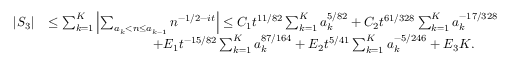<formula> <loc_0><loc_0><loc_500><loc_500>\begin{array} { r l } { | S _ { 3 } | } & { \leq \sum _ { k = 1 } ^ { K } \left | \sum _ { a _ { k } < n \leq a _ { k - 1 } } n ^ { - 1 / 2 - i t } \right | \leq C _ { 1 } t ^ { 1 1 / 8 2 } \sum _ { k = 1 } ^ { K } a _ { k } ^ { 5 / 8 2 } + C _ { 2 } t ^ { 6 1 / 3 2 8 } \sum _ { k = 1 } ^ { K } a _ { k } ^ { - 1 7 / 3 2 8 } } \\ & { \quad + E _ { 1 } t ^ { - 1 5 / 8 2 } \sum _ { k = 1 } ^ { K } a _ { k } ^ { 8 7 / 1 6 4 } + E _ { 2 } t ^ { 5 / 4 1 } \sum _ { k = 1 } ^ { K } a _ { k } ^ { - 5 / 2 4 6 } + E _ { 3 } K . } \end{array}</formula> 